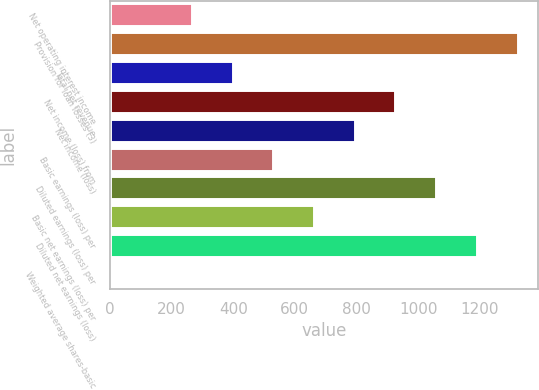Convert chart. <chart><loc_0><loc_0><loc_500><loc_500><bar_chart><fcel>Net operating interest income<fcel>Provision for loan losses (3)<fcel>Total net revenue<fcel>Net income (loss) from<fcel>Net income (loss)<fcel>Basic earnings (loss) per<fcel>Diluted earnings (loss) per<fcel>Basic net earnings (loss) per<fcel>Diluted net earnings (loss)<fcel>Weighted average shares-basic<nl><fcel>265.4<fcel>1323<fcel>397.6<fcel>926.4<fcel>794.2<fcel>529.8<fcel>1058.6<fcel>662<fcel>1190.8<fcel>1<nl></chart> 